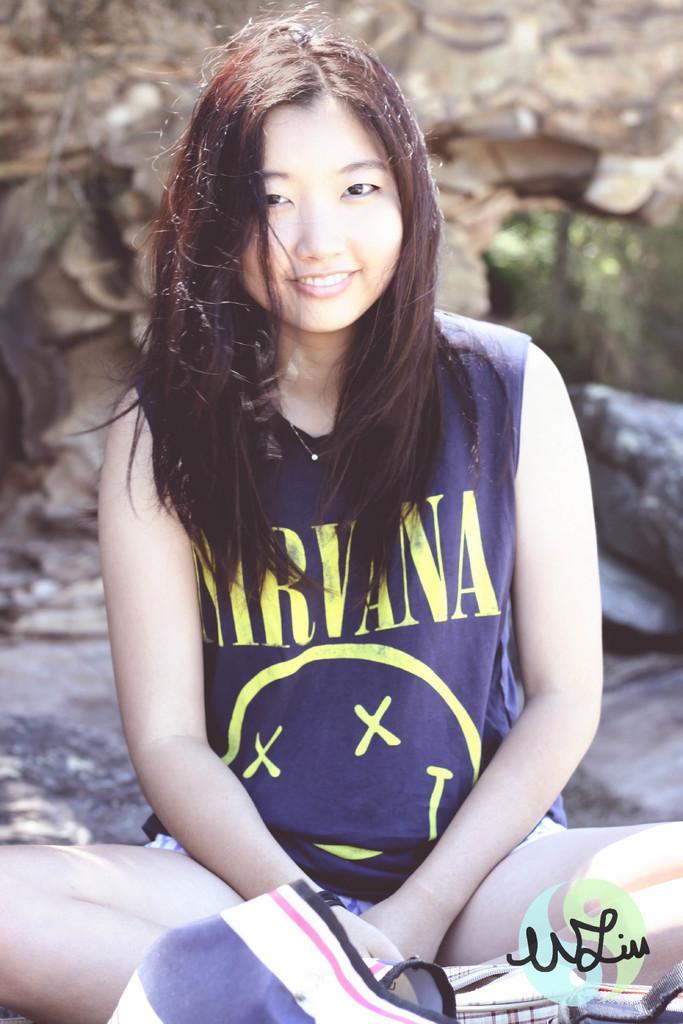In one or two sentences, can you explain what this image depicts? In this image we can see a woman sitting on the ground. On the backside we can see the rocks. 